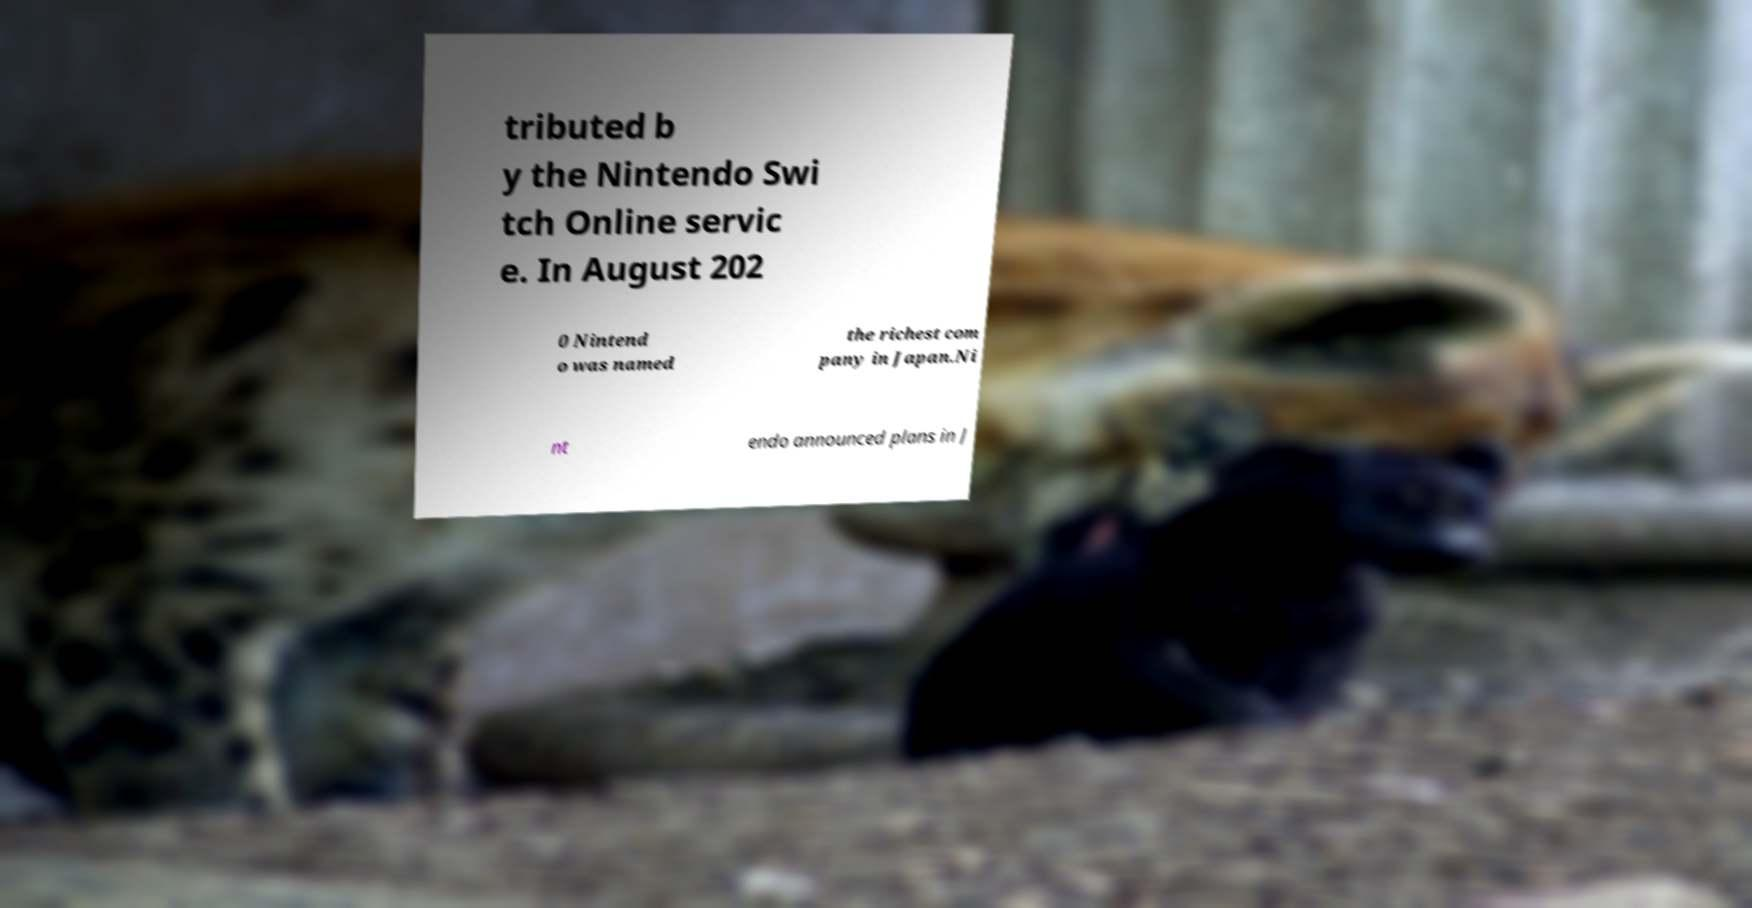For documentation purposes, I need the text within this image transcribed. Could you provide that? tributed b y the Nintendo Swi tch Online servic e. In August 202 0 Nintend o was named the richest com pany in Japan.Ni nt endo announced plans in J 